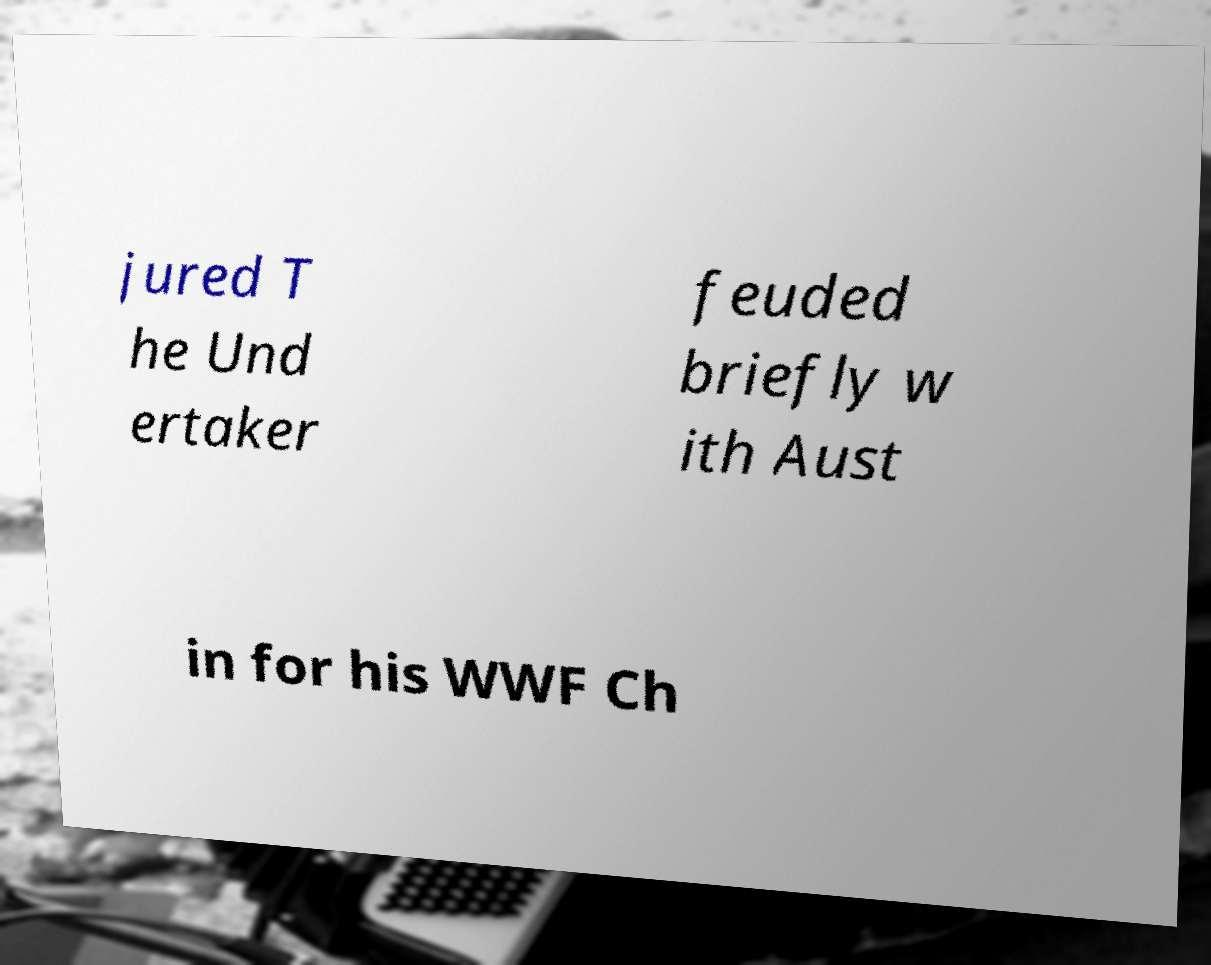I need the written content from this picture converted into text. Can you do that? jured T he Und ertaker feuded briefly w ith Aust in for his WWF Ch 